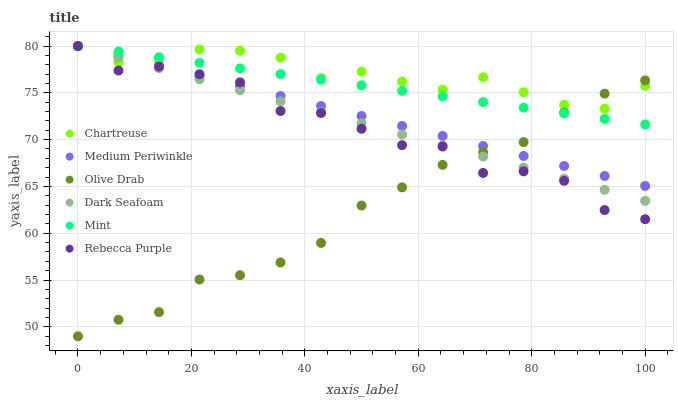Does Olive Drab have the minimum area under the curve?
Answer yes or no. Yes. Does Chartreuse have the maximum area under the curve?
Answer yes or no. Yes. Does Dark Seafoam have the minimum area under the curve?
Answer yes or no. No. Does Dark Seafoam have the maximum area under the curve?
Answer yes or no. No. Is Dark Seafoam the smoothest?
Answer yes or no. Yes. Is Rebecca Purple the roughest?
Answer yes or no. Yes. Is Chartreuse the smoothest?
Answer yes or no. No. Is Chartreuse the roughest?
Answer yes or no. No. Does Olive Drab have the lowest value?
Answer yes or no. Yes. Does Dark Seafoam have the lowest value?
Answer yes or no. No. Does Mint have the highest value?
Answer yes or no. Yes. Does Olive Drab have the highest value?
Answer yes or no. No. Does Rebecca Purple intersect Medium Periwinkle?
Answer yes or no. Yes. Is Rebecca Purple less than Medium Periwinkle?
Answer yes or no. No. Is Rebecca Purple greater than Medium Periwinkle?
Answer yes or no. No. 